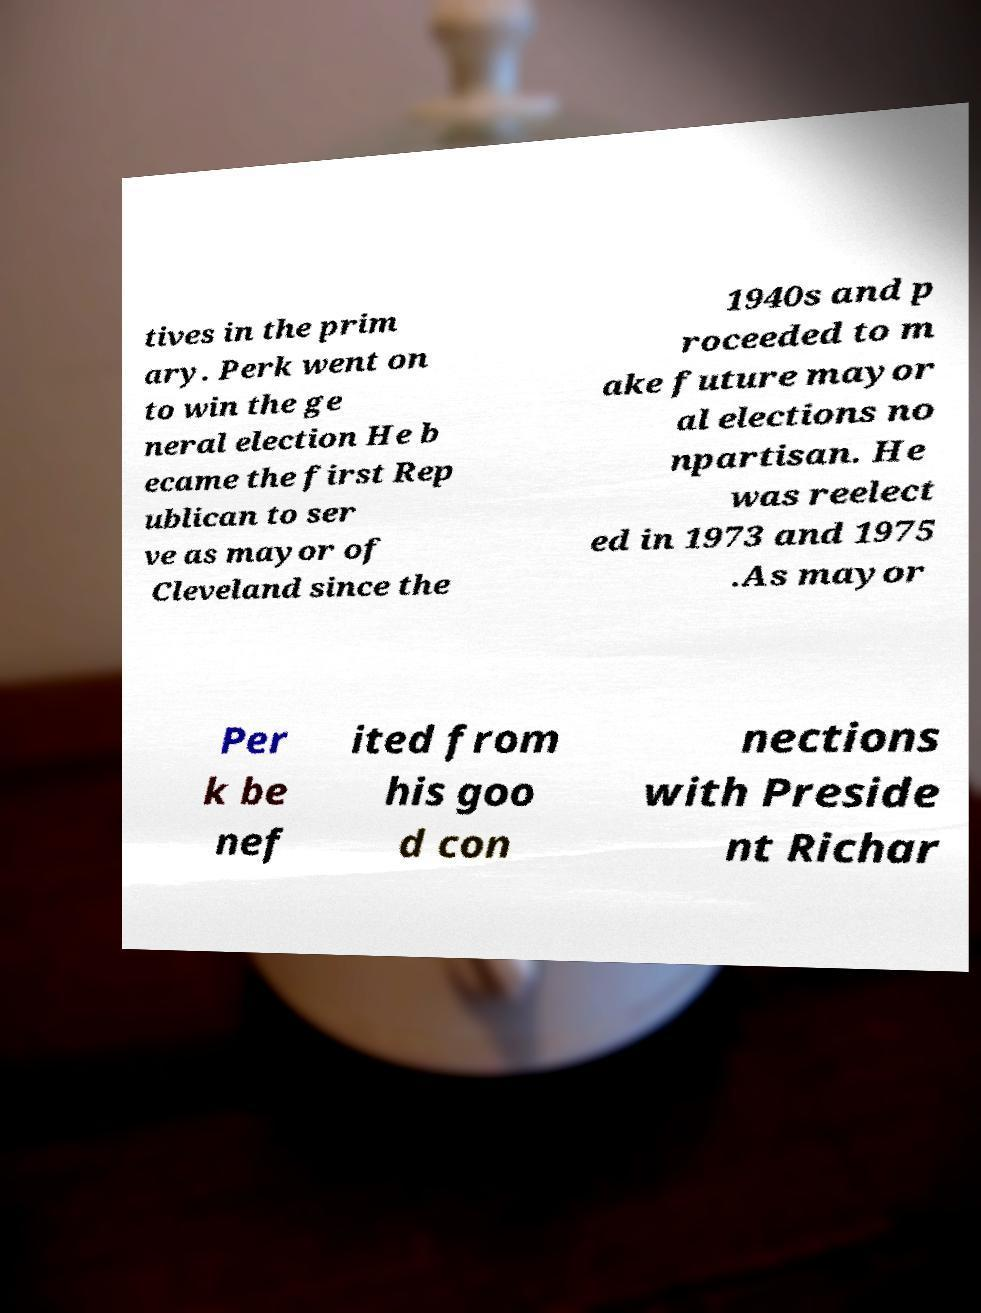Can you accurately transcribe the text from the provided image for me? tives in the prim ary. Perk went on to win the ge neral election He b ecame the first Rep ublican to ser ve as mayor of Cleveland since the 1940s and p roceeded to m ake future mayor al elections no npartisan. He was reelect ed in 1973 and 1975 .As mayor Per k be nef ited from his goo d con nections with Preside nt Richar 